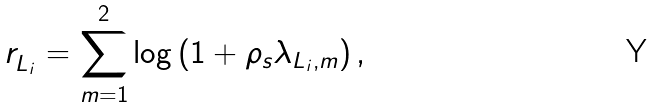<formula> <loc_0><loc_0><loc_500><loc_500>r _ { L _ { i } } ^ { \sl } = \sum _ { m = 1 } ^ { 2 } \log \left ( 1 + \rho _ { s } \lambda _ { L _ { i } , m } \right ) ,</formula> 